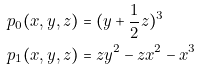Convert formula to latex. <formula><loc_0><loc_0><loc_500><loc_500>p _ { 0 } ( x , y , z ) & = ( y + \frac { 1 } { 2 } z ) ^ { 3 } \\ p _ { 1 } ( x , y , z ) & = z y ^ { 2 } - z x ^ { 2 } - x ^ { 3 }</formula> 